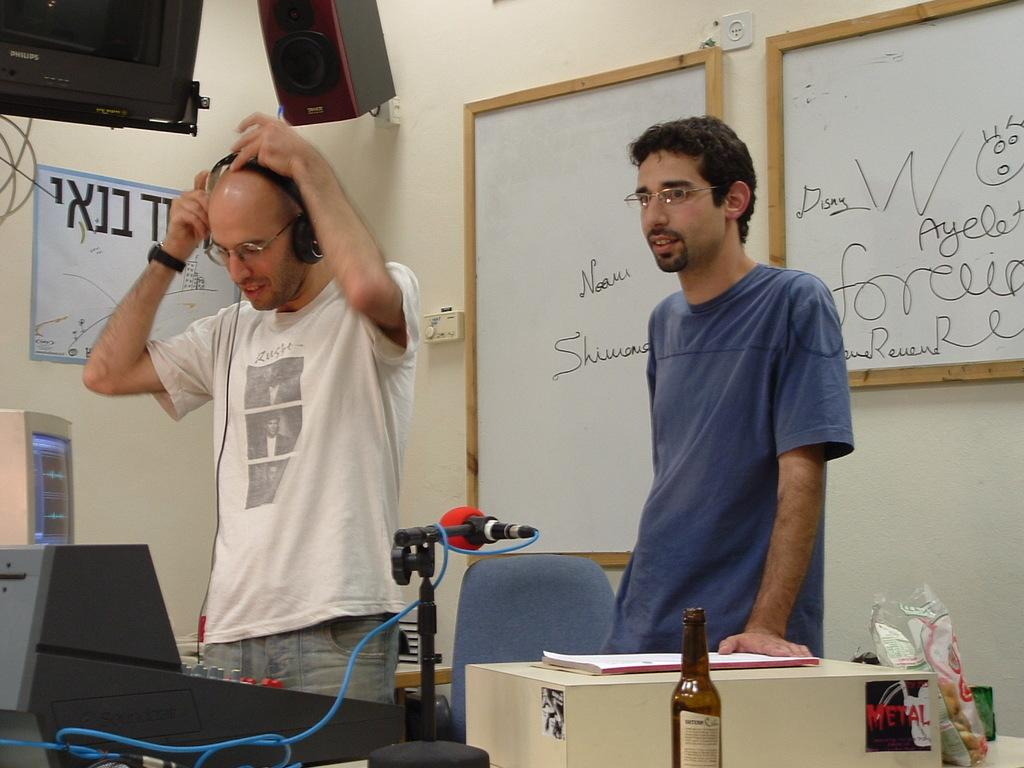Provide a one-sentence caption for the provided image. Two men wearing glasses stand in a room with a computer, microphone, and sound board. 